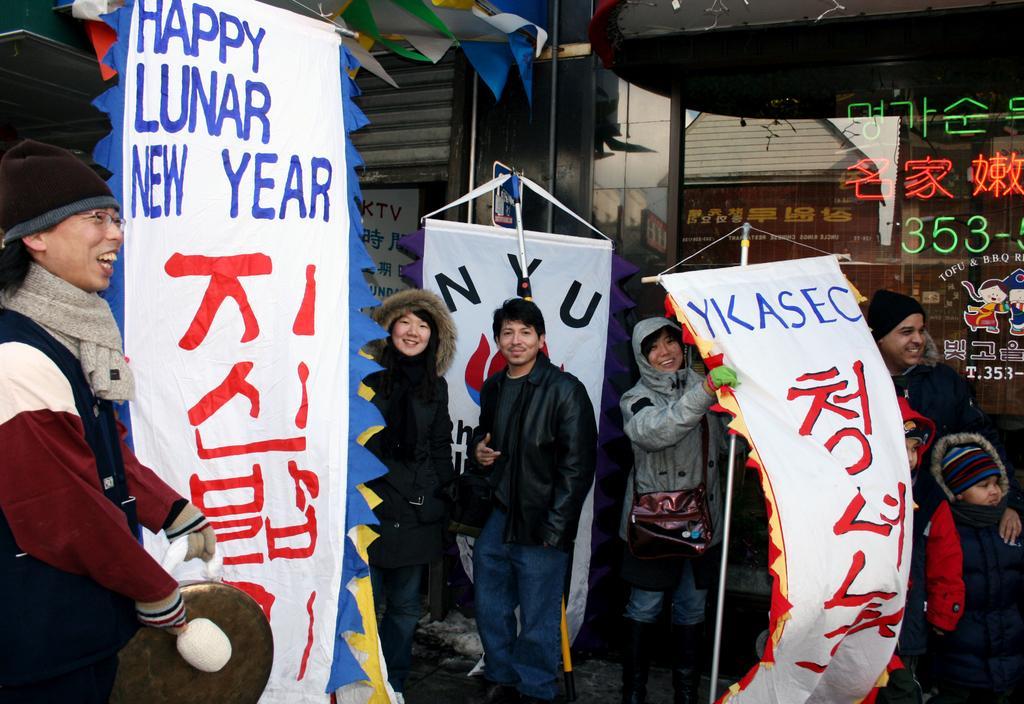Please provide a concise description of this image. In this picture we can see a group of people, here we can see banners, decorative objects and some objects. 